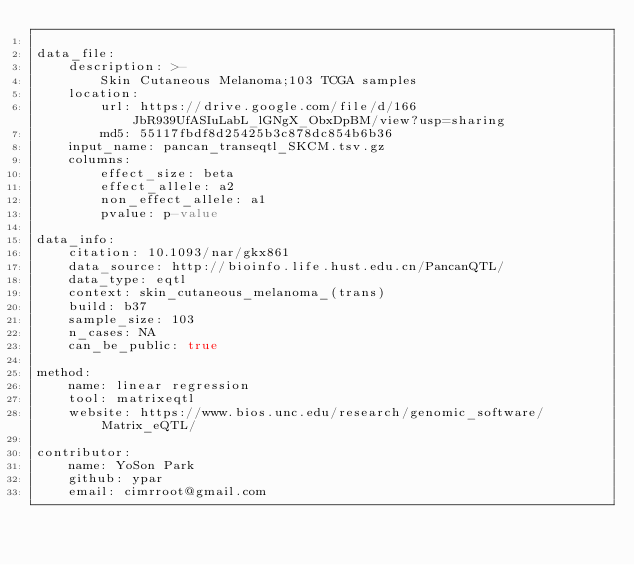Convert code to text. <code><loc_0><loc_0><loc_500><loc_500><_YAML_>
data_file:
    description: >-
        Skin Cutaneous Melanoma;103 TCGA samples
    location:
        url: https://drive.google.com/file/d/166JbR939UfASIuLabL_lGNgX_ObxDpBM/view?usp=sharing
        md5: 55117fbdf8d25425b3c878dc854b6b36
    input_name: pancan_transeqtl_SKCM.tsv.gz
    columns:
        effect_size: beta
        effect_allele: a2
        non_effect_allele: a1
        pvalue: p-value

data_info:
    citation: 10.1093/nar/gkx861
    data_source: http://bioinfo.life.hust.edu.cn/PancanQTL/
    data_type: eqtl
    context: skin_cutaneous_melanoma_(trans)
    build: b37
    sample_size: 103
    n_cases: NA
    can_be_public: true

method:
    name: linear regression
    tool: matrixeqtl
    website: https://www.bios.unc.edu/research/genomic_software/Matrix_eQTL/

contributor:
    name: YoSon Park
    github: ypar
    email: cimrroot@gmail.com

</code> 